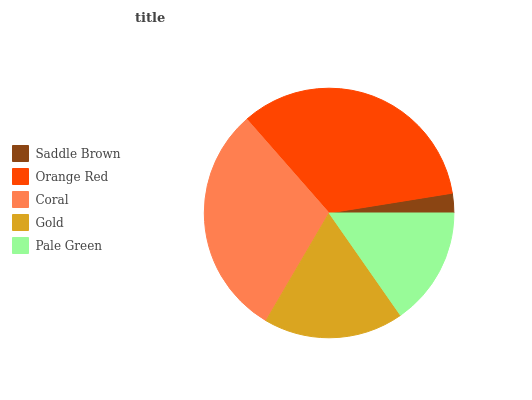Is Saddle Brown the minimum?
Answer yes or no. Yes. Is Orange Red the maximum?
Answer yes or no. Yes. Is Coral the minimum?
Answer yes or no. No. Is Coral the maximum?
Answer yes or no. No. Is Orange Red greater than Coral?
Answer yes or no. Yes. Is Coral less than Orange Red?
Answer yes or no. Yes. Is Coral greater than Orange Red?
Answer yes or no. No. Is Orange Red less than Coral?
Answer yes or no. No. Is Gold the high median?
Answer yes or no. Yes. Is Gold the low median?
Answer yes or no. Yes. Is Saddle Brown the high median?
Answer yes or no. No. Is Pale Green the low median?
Answer yes or no. No. 